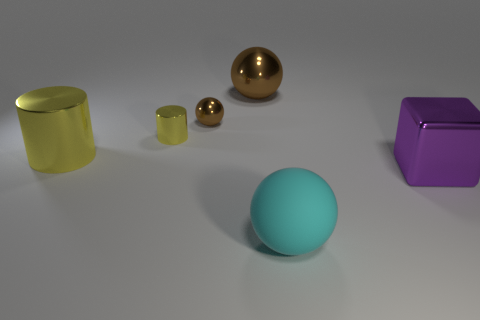Add 4 big yellow things. How many objects exist? 10 Subtract all cubes. How many objects are left? 5 Add 5 big purple objects. How many big purple objects are left? 6 Add 3 big cyan rubber things. How many big cyan rubber things exist? 4 Subtract 0 blue spheres. How many objects are left? 6 Subtract all big yellow cylinders. Subtract all big brown metal objects. How many objects are left? 4 